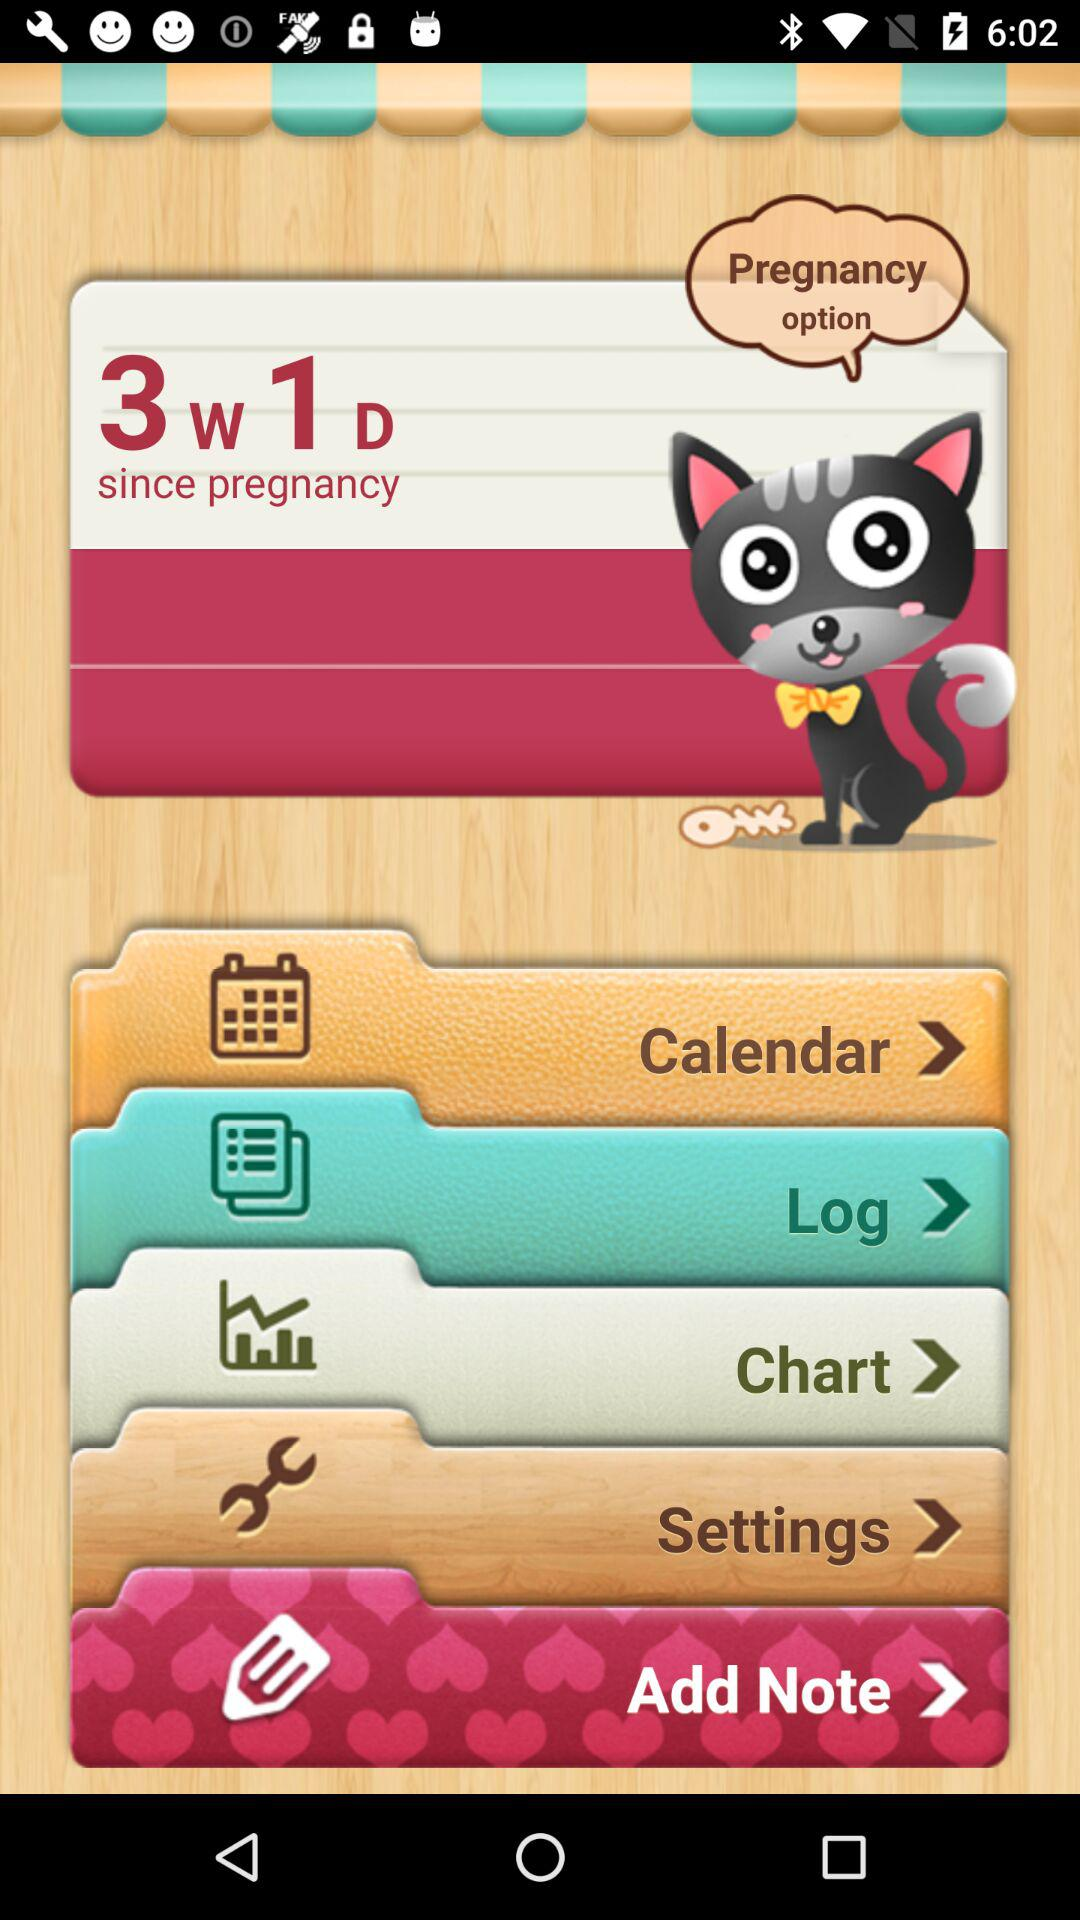What is the current duration of pregnancy shown? The current duration of pregnancy is 3 weeks and 1 day. 